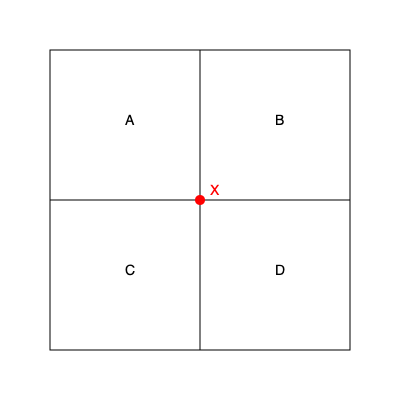In the floor plan of a community center shown above, point X represents the central meeting area. If you enter the building from the bottom of the diagram and turn right, which room would you be in? To solve this problem, we need to visualize the floor plan from the perspective of someone entering the building:

1. The diagram shows a top-down view of the community center divided into four rooms: A, B, C, and D.
2. We're told to imagine entering from the bottom of the diagram. This means we're entering from the south side of the building.
3. The instruction is to turn right after entering. In a top-down view, turning right means moving to the east (or right on the diagram).
4. Looking at the diagram, if we enter from the bottom (south) and turn right (east), we would end up in the bottom-right room.
5. The bottom-right room is labeled as room D.

Therefore, if you enter the building from the bottom of the diagram and turn right, you would be in room D.
Answer: D 